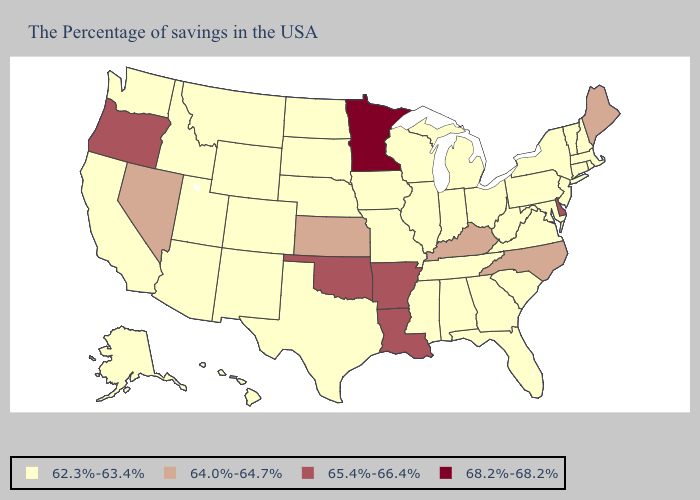What is the lowest value in the USA?
Short answer required. 62.3%-63.4%. Does Delaware have the highest value in the USA?
Be succinct. No. Which states hav the highest value in the West?
Answer briefly. Oregon. What is the value of Connecticut?
Quick response, please. 62.3%-63.4%. Does Louisiana have the lowest value in the USA?
Be succinct. No. Does Rhode Island have a lower value than New York?
Quick response, please. No. What is the highest value in the West ?
Short answer required. 65.4%-66.4%. Does South Carolina have the lowest value in the USA?
Quick response, please. Yes. Does the first symbol in the legend represent the smallest category?
Quick response, please. Yes. Name the states that have a value in the range 68.2%-68.2%?
Write a very short answer. Minnesota. What is the lowest value in the West?
Write a very short answer. 62.3%-63.4%. Does Nevada have the lowest value in the West?
Short answer required. No. What is the value of Alabama?
Short answer required. 62.3%-63.4%. What is the highest value in states that border New Mexico?
Quick response, please. 65.4%-66.4%. Which states hav the highest value in the South?
Be succinct. Delaware, Louisiana, Arkansas, Oklahoma. 